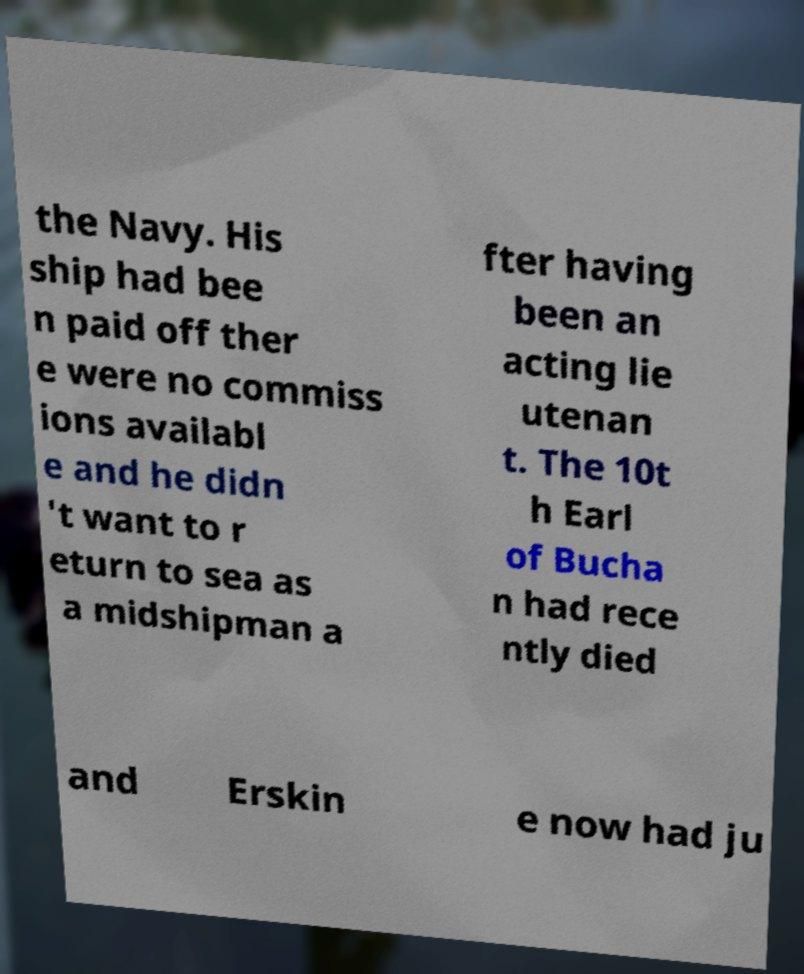What messages or text are displayed in this image? I need them in a readable, typed format. the Navy. His ship had bee n paid off ther e were no commiss ions availabl e and he didn 't want to r eturn to sea as a midshipman a fter having been an acting lie utenan t. The 10t h Earl of Bucha n had rece ntly died and Erskin e now had ju 